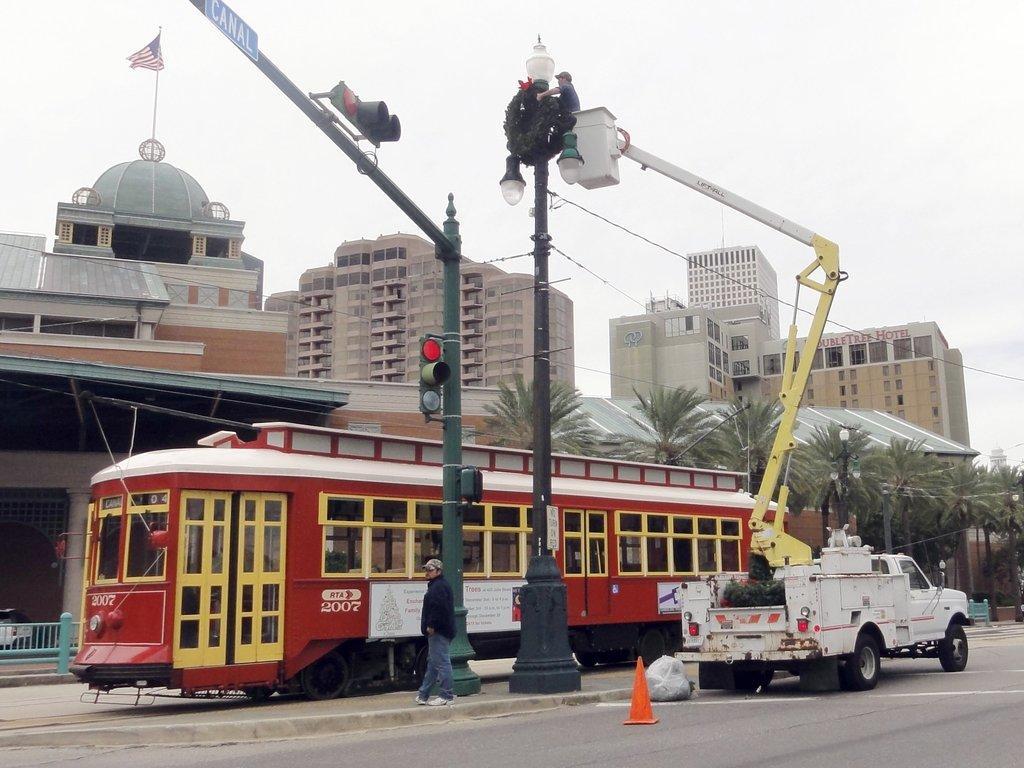Please provide a concise description of this image. In this picture I can see there is a train and it has windows and a door. There are poles with traffic lights and there are trees and there are few buildings in the backdrop and it has a flag. The sky is clear. 